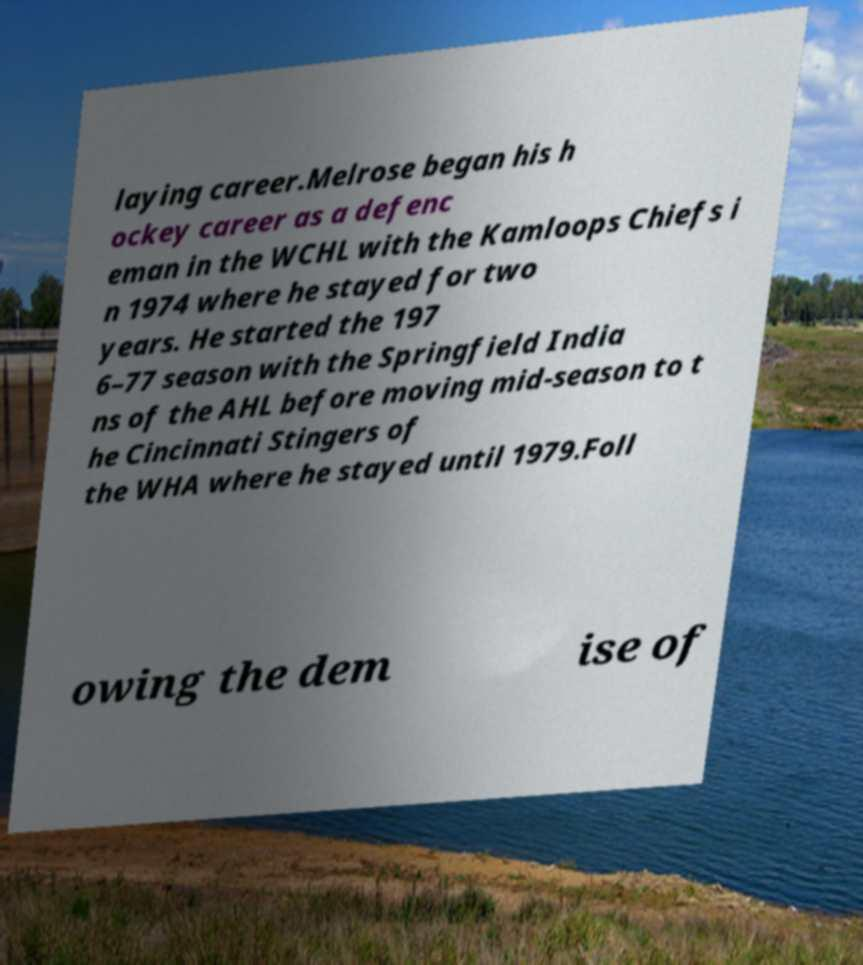Please read and relay the text visible in this image. What does it say? laying career.Melrose began his h ockey career as a defenc eman in the WCHL with the Kamloops Chiefs i n 1974 where he stayed for two years. He started the 197 6–77 season with the Springfield India ns of the AHL before moving mid-season to t he Cincinnati Stingers of the WHA where he stayed until 1979.Foll owing the dem ise of 